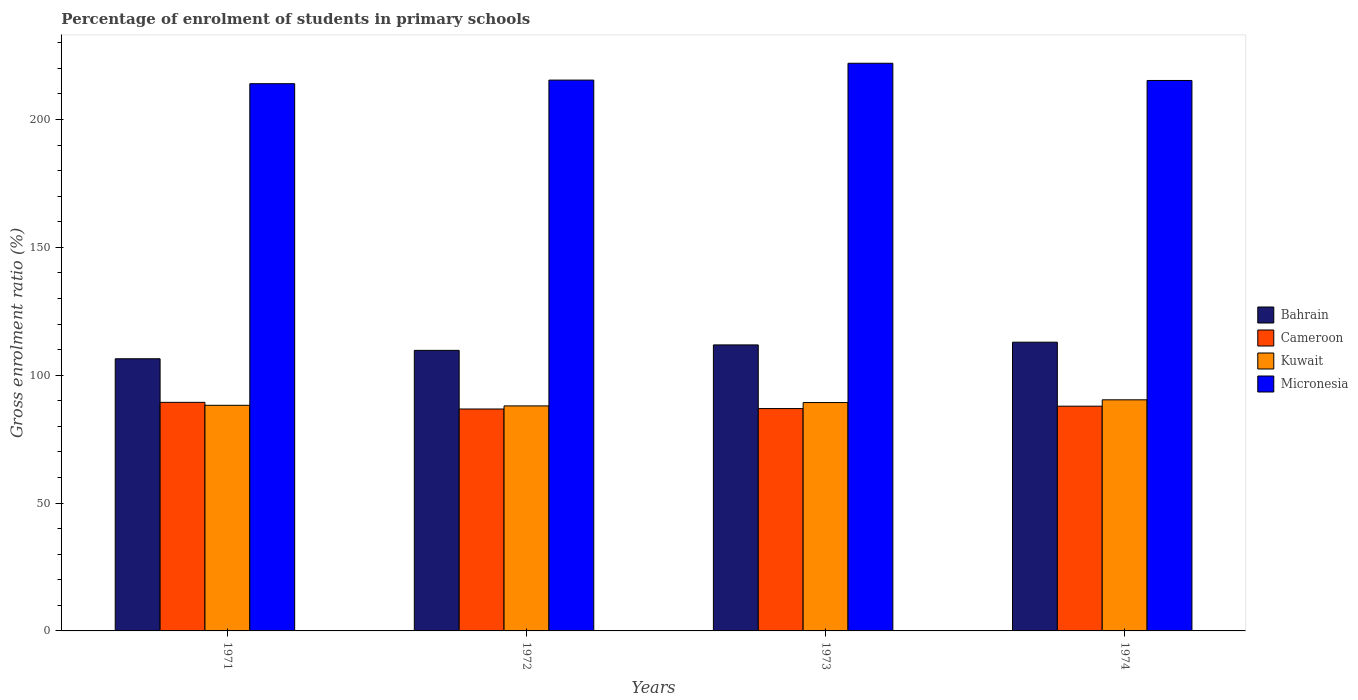How many different coloured bars are there?
Give a very brief answer. 4. Are the number of bars per tick equal to the number of legend labels?
Give a very brief answer. Yes. How many bars are there on the 4th tick from the right?
Provide a succinct answer. 4. What is the label of the 1st group of bars from the left?
Ensure brevity in your answer.  1971. What is the percentage of students enrolled in primary schools in Micronesia in 1973?
Offer a terse response. 221.99. Across all years, what is the maximum percentage of students enrolled in primary schools in Bahrain?
Keep it short and to the point. 112.91. Across all years, what is the minimum percentage of students enrolled in primary schools in Kuwait?
Keep it short and to the point. 88. In which year was the percentage of students enrolled in primary schools in Bahrain maximum?
Provide a succinct answer. 1974. In which year was the percentage of students enrolled in primary schools in Kuwait minimum?
Offer a terse response. 1972. What is the total percentage of students enrolled in primary schools in Bahrain in the graph?
Offer a terse response. 440.9. What is the difference between the percentage of students enrolled in primary schools in Cameroon in 1971 and that in 1974?
Your answer should be very brief. 1.5. What is the difference between the percentage of students enrolled in primary schools in Cameroon in 1972 and the percentage of students enrolled in primary schools in Kuwait in 1971?
Provide a succinct answer. -1.45. What is the average percentage of students enrolled in primary schools in Cameroon per year?
Ensure brevity in your answer.  87.75. In the year 1972, what is the difference between the percentage of students enrolled in primary schools in Kuwait and percentage of students enrolled in primary schools in Bahrain?
Your response must be concise. -21.72. What is the ratio of the percentage of students enrolled in primary schools in Bahrain in 1971 to that in 1972?
Provide a short and direct response. 0.97. Is the percentage of students enrolled in primary schools in Bahrain in 1971 less than that in 1972?
Offer a terse response. Yes. Is the difference between the percentage of students enrolled in primary schools in Kuwait in 1971 and 1973 greater than the difference between the percentage of students enrolled in primary schools in Bahrain in 1971 and 1973?
Keep it short and to the point. Yes. What is the difference between the highest and the second highest percentage of students enrolled in primary schools in Bahrain?
Provide a short and direct response. 1.06. What is the difference between the highest and the lowest percentage of students enrolled in primary schools in Cameroon?
Keep it short and to the point. 2.6. In how many years, is the percentage of students enrolled in primary schools in Cameroon greater than the average percentage of students enrolled in primary schools in Cameroon taken over all years?
Provide a short and direct response. 2. Is it the case that in every year, the sum of the percentage of students enrolled in primary schools in Micronesia and percentage of students enrolled in primary schools in Cameroon is greater than the sum of percentage of students enrolled in primary schools in Bahrain and percentage of students enrolled in primary schools in Kuwait?
Your answer should be compact. Yes. What does the 2nd bar from the left in 1971 represents?
Your answer should be very brief. Cameroon. What does the 1st bar from the right in 1974 represents?
Offer a very short reply. Micronesia. Are all the bars in the graph horizontal?
Offer a terse response. No. What is the difference between two consecutive major ticks on the Y-axis?
Provide a short and direct response. 50. Does the graph contain grids?
Make the answer very short. No. How many legend labels are there?
Your answer should be very brief. 4. What is the title of the graph?
Your response must be concise. Percentage of enrolment of students in primary schools. What is the label or title of the X-axis?
Provide a short and direct response. Years. What is the label or title of the Y-axis?
Give a very brief answer. Gross enrolment ratio (%). What is the Gross enrolment ratio (%) of Bahrain in 1971?
Offer a very short reply. 106.43. What is the Gross enrolment ratio (%) in Cameroon in 1971?
Give a very brief answer. 89.38. What is the Gross enrolment ratio (%) of Kuwait in 1971?
Keep it short and to the point. 88.23. What is the Gross enrolment ratio (%) of Micronesia in 1971?
Give a very brief answer. 214. What is the Gross enrolment ratio (%) in Bahrain in 1972?
Make the answer very short. 109.71. What is the Gross enrolment ratio (%) in Cameroon in 1972?
Offer a terse response. 86.78. What is the Gross enrolment ratio (%) in Kuwait in 1972?
Make the answer very short. 88. What is the Gross enrolment ratio (%) of Micronesia in 1972?
Your response must be concise. 215.41. What is the Gross enrolment ratio (%) of Bahrain in 1973?
Provide a succinct answer. 111.85. What is the Gross enrolment ratio (%) in Cameroon in 1973?
Ensure brevity in your answer.  86.95. What is the Gross enrolment ratio (%) of Kuwait in 1973?
Give a very brief answer. 89.31. What is the Gross enrolment ratio (%) in Micronesia in 1973?
Provide a succinct answer. 221.99. What is the Gross enrolment ratio (%) in Bahrain in 1974?
Make the answer very short. 112.91. What is the Gross enrolment ratio (%) in Cameroon in 1974?
Ensure brevity in your answer.  87.89. What is the Gross enrolment ratio (%) in Kuwait in 1974?
Keep it short and to the point. 90.38. What is the Gross enrolment ratio (%) in Micronesia in 1974?
Give a very brief answer. 215.26. Across all years, what is the maximum Gross enrolment ratio (%) in Bahrain?
Provide a short and direct response. 112.91. Across all years, what is the maximum Gross enrolment ratio (%) in Cameroon?
Offer a very short reply. 89.38. Across all years, what is the maximum Gross enrolment ratio (%) of Kuwait?
Provide a short and direct response. 90.38. Across all years, what is the maximum Gross enrolment ratio (%) in Micronesia?
Your answer should be compact. 221.99. Across all years, what is the minimum Gross enrolment ratio (%) of Bahrain?
Ensure brevity in your answer.  106.43. Across all years, what is the minimum Gross enrolment ratio (%) of Cameroon?
Your response must be concise. 86.78. Across all years, what is the minimum Gross enrolment ratio (%) in Kuwait?
Offer a terse response. 88. Across all years, what is the minimum Gross enrolment ratio (%) in Micronesia?
Your answer should be very brief. 214. What is the total Gross enrolment ratio (%) of Bahrain in the graph?
Offer a terse response. 440.9. What is the total Gross enrolment ratio (%) in Cameroon in the graph?
Your response must be concise. 351. What is the total Gross enrolment ratio (%) in Kuwait in the graph?
Ensure brevity in your answer.  355.91. What is the total Gross enrolment ratio (%) in Micronesia in the graph?
Make the answer very short. 866.66. What is the difference between the Gross enrolment ratio (%) of Bahrain in 1971 and that in 1972?
Your response must be concise. -3.28. What is the difference between the Gross enrolment ratio (%) in Cameroon in 1971 and that in 1972?
Provide a succinct answer. 2.6. What is the difference between the Gross enrolment ratio (%) of Kuwait in 1971 and that in 1972?
Provide a succinct answer. 0.24. What is the difference between the Gross enrolment ratio (%) in Micronesia in 1971 and that in 1972?
Your response must be concise. -1.41. What is the difference between the Gross enrolment ratio (%) of Bahrain in 1971 and that in 1973?
Ensure brevity in your answer.  -5.42. What is the difference between the Gross enrolment ratio (%) in Cameroon in 1971 and that in 1973?
Offer a terse response. 2.43. What is the difference between the Gross enrolment ratio (%) in Kuwait in 1971 and that in 1973?
Offer a very short reply. -1.07. What is the difference between the Gross enrolment ratio (%) in Micronesia in 1971 and that in 1973?
Ensure brevity in your answer.  -7.99. What is the difference between the Gross enrolment ratio (%) of Bahrain in 1971 and that in 1974?
Make the answer very short. -6.48. What is the difference between the Gross enrolment ratio (%) in Cameroon in 1971 and that in 1974?
Ensure brevity in your answer.  1.5. What is the difference between the Gross enrolment ratio (%) in Kuwait in 1971 and that in 1974?
Keep it short and to the point. -2.15. What is the difference between the Gross enrolment ratio (%) in Micronesia in 1971 and that in 1974?
Make the answer very short. -1.26. What is the difference between the Gross enrolment ratio (%) in Bahrain in 1972 and that in 1973?
Ensure brevity in your answer.  -2.14. What is the difference between the Gross enrolment ratio (%) in Cameroon in 1972 and that in 1973?
Offer a terse response. -0.18. What is the difference between the Gross enrolment ratio (%) of Kuwait in 1972 and that in 1973?
Provide a short and direct response. -1.31. What is the difference between the Gross enrolment ratio (%) of Micronesia in 1972 and that in 1973?
Make the answer very short. -6.58. What is the difference between the Gross enrolment ratio (%) of Bahrain in 1972 and that in 1974?
Ensure brevity in your answer.  -3.2. What is the difference between the Gross enrolment ratio (%) in Cameroon in 1972 and that in 1974?
Make the answer very short. -1.11. What is the difference between the Gross enrolment ratio (%) in Kuwait in 1972 and that in 1974?
Ensure brevity in your answer.  -2.38. What is the difference between the Gross enrolment ratio (%) in Micronesia in 1972 and that in 1974?
Your answer should be compact. 0.15. What is the difference between the Gross enrolment ratio (%) of Bahrain in 1973 and that in 1974?
Make the answer very short. -1.06. What is the difference between the Gross enrolment ratio (%) of Cameroon in 1973 and that in 1974?
Give a very brief answer. -0.93. What is the difference between the Gross enrolment ratio (%) in Kuwait in 1973 and that in 1974?
Provide a succinct answer. -1.07. What is the difference between the Gross enrolment ratio (%) of Micronesia in 1973 and that in 1974?
Provide a succinct answer. 6.74. What is the difference between the Gross enrolment ratio (%) in Bahrain in 1971 and the Gross enrolment ratio (%) in Cameroon in 1972?
Give a very brief answer. 19.65. What is the difference between the Gross enrolment ratio (%) in Bahrain in 1971 and the Gross enrolment ratio (%) in Kuwait in 1972?
Ensure brevity in your answer.  18.44. What is the difference between the Gross enrolment ratio (%) in Bahrain in 1971 and the Gross enrolment ratio (%) in Micronesia in 1972?
Your answer should be compact. -108.98. What is the difference between the Gross enrolment ratio (%) in Cameroon in 1971 and the Gross enrolment ratio (%) in Kuwait in 1972?
Make the answer very short. 1.39. What is the difference between the Gross enrolment ratio (%) of Cameroon in 1971 and the Gross enrolment ratio (%) of Micronesia in 1972?
Offer a terse response. -126.03. What is the difference between the Gross enrolment ratio (%) of Kuwait in 1971 and the Gross enrolment ratio (%) of Micronesia in 1972?
Keep it short and to the point. -127.18. What is the difference between the Gross enrolment ratio (%) in Bahrain in 1971 and the Gross enrolment ratio (%) in Cameroon in 1973?
Your response must be concise. 19.48. What is the difference between the Gross enrolment ratio (%) in Bahrain in 1971 and the Gross enrolment ratio (%) in Kuwait in 1973?
Offer a very short reply. 17.12. What is the difference between the Gross enrolment ratio (%) in Bahrain in 1971 and the Gross enrolment ratio (%) in Micronesia in 1973?
Ensure brevity in your answer.  -115.56. What is the difference between the Gross enrolment ratio (%) of Cameroon in 1971 and the Gross enrolment ratio (%) of Kuwait in 1973?
Provide a succinct answer. 0.08. What is the difference between the Gross enrolment ratio (%) in Cameroon in 1971 and the Gross enrolment ratio (%) in Micronesia in 1973?
Your response must be concise. -132.61. What is the difference between the Gross enrolment ratio (%) of Kuwait in 1971 and the Gross enrolment ratio (%) of Micronesia in 1973?
Your response must be concise. -133.76. What is the difference between the Gross enrolment ratio (%) in Bahrain in 1971 and the Gross enrolment ratio (%) in Cameroon in 1974?
Keep it short and to the point. 18.54. What is the difference between the Gross enrolment ratio (%) of Bahrain in 1971 and the Gross enrolment ratio (%) of Kuwait in 1974?
Offer a terse response. 16.05. What is the difference between the Gross enrolment ratio (%) of Bahrain in 1971 and the Gross enrolment ratio (%) of Micronesia in 1974?
Make the answer very short. -108.83. What is the difference between the Gross enrolment ratio (%) in Cameroon in 1971 and the Gross enrolment ratio (%) in Kuwait in 1974?
Give a very brief answer. -1. What is the difference between the Gross enrolment ratio (%) in Cameroon in 1971 and the Gross enrolment ratio (%) in Micronesia in 1974?
Provide a succinct answer. -125.87. What is the difference between the Gross enrolment ratio (%) in Kuwait in 1971 and the Gross enrolment ratio (%) in Micronesia in 1974?
Your answer should be compact. -127.02. What is the difference between the Gross enrolment ratio (%) in Bahrain in 1972 and the Gross enrolment ratio (%) in Cameroon in 1973?
Keep it short and to the point. 22.76. What is the difference between the Gross enrolment ratio (%) of Bahrain in 1972 and the Gross enrolment ratio (%) of Kuwait in 1973?
Provide a short and direct response. 20.4. What is the difference between the Gross enrolment ratio (%) in Bahrain in 1972 and the Gross enrolment ratio (%) in Micronesia in 1973?
Your answer should be very brief. -112.28. What is the difference between the Gross enrolment ratio (%) of Cameroon in 1972 and the Gross enrolment ratio (%) of Kuwait in 1973?
Offer a terse response. -2.53. What is the difference between the Gross enrolment ratio (%) in Cameroon in 1972 and the Gross enrolment ratio (%) in Micronesia in 1973?
Ensure brevity in your answer.  -135.21. What is the difference between the Gross enrolment ratio (%) of Kuwait in 1972 and the Gross enrolment ratio (%) of Micronesia in 1973?
Provide a short and direct response. -134. What is the difference between the Gross enrolment ratio (%) in Bahrain in 1972 and the Gross enrolment ratio (%) in Cameroon in 1974?
Provide a succinct answer. 21.83. What is the difference between the Gross enrolment ratio (%) in Bahrain in 1972 and the Gross enrolment ratio (%) in Kuwait in 1974?
Your answer should be very brief. 19.33. What is the difference between the Gross enrolment ratio (%) of Bahrain in 1972 and the Gross enrolment ratio (%) of Micronesia in 1974?
Offer a terse response. -105.55. What is the difference between the Gross enrolment ratio (%) in Cameroon in 1972 and the Gross enrolment ratio (%) in Kuwait in 1974?
Ensure brevity in your answer.  -3.6. What is the difference between the Gross enrolment ratio (%) of Cameroon in 1972 and the Gross enrolment ratio (%) of Micronesia in 1974?
Keep it short and to the point. -128.48. What is the difference between the Gross enrolment ratio (%) of Kuwait in 1972 and the Gross enrolment ratio (%) of Micronesia in 1974?
Your answer should be very brief. -127.26. What is the difference between the Gross enrolment ratio (%) in Bahrain in 1973 and the Gross enrolment ratio (%) in Cameroon in 1974?
Your answer should be compact. 23.96. What is the difference between the Gross enrolment ratio (%) of Bahrain in 1973 and the Gross enrolment ratio (%) of Kuwait in 1974?
Your answer should be very brief. 21.47. What is the difference between the Gross enrolment ratio (%) of Bahrain in 1973 and the Gross enrolment ratio (%) of Micronesia in 1974?
Your answer should be compact. -103.41. What is the difference between the Gross enrolment ratio (%) of Cameroon in 1973 and the Gross enrolment ratio (%) of Kuwait in 1974?
Offer a terse response. -3.42. What is the difference between the Gross enrolment ratio (%) in Cameroon in 1973 and the Gross enrolment ratio (%) in Micronesia in 1974?
Keep it short and to the point. -128.3. What is the difference between the Gross enrolment ratio (%) of Kuwait in 1973 and the Gross enrolment ratio (%) of Micronesia in 1974?
Your response must be concise. -125.95. What is the average Gross enrolment ratio (%) in Bahrain per year?
Give a very brief answer. 110.22. What is the average Gross enrolment ratio (%) in Cameroon per year?
Make the answer very short. 87.75. What is the average Gross enrolment ratio (%) in Kuwait per year?
Make the answer very short. 88.98. What is the average Gross enrolment ratio (%) of Micronesia per year?
Your answer should be compact. 216.66. In the year 1971, what is the difference between the Gross enrolment ratio (%) of Bahrain and Gross enrolment ratio (%) of Cameroon?
Your answer should be compact. 17.05. In the year 1971, what is the difference between the Gross enrolment ratio (%) of Bahrain and Gross enrolment ratio (%) of Kuwait?
Your response must be concise. 18.2. In the year 1971, what is the difference between the Gross enrolment ratio (%) of Bahrain and Gross enrolment ratio (%) of Micronesia?
Provide a succinct answer. -107.57. In the year 1971, what is the difference between the Gross enrolment ratio (%) of Cameroon and Gross enrolment ratio (%) of Kuwait?
Give a very brief answer. 1.15. In the year 1971, what is the difference between the Gross enrolment ratio (%) of Cameroon and Gross enrolment ratio (%) of Micronesia?
Offer a terse response. -124.62. In the year 1971, what is the difference between the Gross enrolment ratio (%) in Kuwait and Gross enrolment ratio (%) in Micronesia?
Provide a succinct answer. -125.77. In the year 1972, what is the difference between the Gross enrolment ratio (%) in Bahrain and Gross enrolment ratio (%) in Cameroon?
Offer a very short reply. 22.93. In the year 1972, what is the difference between the Gross enrolment ratio (%) in Bahrain and Gross enrolment ratio (%) in Kuwait?
Your answer should be compact. 21.72. In the year 1972, what is the difference between the Gross enrolment ratio (%) of Bahrain and Gross enrolment ratio (%) of Micronesia?
Ensure brevity in your answer.  -105.7. In the year 1972, what is the difference between the Gross enrolment ratio (%) in Cameroon and Gross enrolment ratio (%) in Kuwait?
Ensure brevity in your answer.  -1.22. In the year 1972, what is the difference between the Gross enrolment ratio (%) in Cameroon and Gross enrolment ratio (%) in Micronesia?
Offer a terse response. -128.63. In the year 1972, what is the difference between the Gross enrolment ratio (%) of Kuwait and Gross enrolment ratio (%) of Micronesia?
Your answer should be very brief. -127.41. In the year 1973, what is the difference between the Gross enrolment ratio (%) in Bahrain and Gross enrolment ratio (%) in Cameroon?
Make the answer very short. 24.89. In the year 1973, what is the difference between the Gross enrolment ratio (%) of Bahrain and Gross enrolment ratio (%) of Kuwait?
Your response must be concise. 22.54. In the year 1973, what is the difference between the Gross enrolment ratio (%) of Bahrain and Gross enrolment ratio (%) of Micronesia?
Your response must be concise. -110.14. In the year 1973, what is the difference between the Gross enrolment ratio (%) in Cameroon and Gross enrolment ratio (%) in Kuwait?
Keep it short and to the point. -2.35. In the year 1973, what is the difference between the Gross enrolment ratio (%) in Cameroon and Gross enrolment ratio (%) in Micronesia?
Provide a succinct answer. -135.04. In the year 1973, what is the difference between the Gross enrolment ratio (%) of Kuwait and Gross enrolment ratio (%) of Micronesia?
Your answer should be compact. -132.69. In the year 1974, what is the difference between the Gross enrolment ratio (%) in Bahrain and Gross enrolment ratio (%) in Cameroon?
Keep it short and to the point. 25.02. In the year 1974, what is the difference between the Gross enrolment ratio (%) in Bahrain and Gross enrolment ratio (%) in Kuwait?
Provide a succinct answer. 22.53. In the year 1974, what is the difference between the Gross enrolment ratio (%) of Bahrain and Gross enrolment ratio (%) of Micronesia?
Ensure brevity in your answer.  -102.35. In the year 1974, what is the difference between the Gross enrolment ratio (%) in Cameroon and Gross enrolment ratio (%) in Kuwait?
Ensure brevity in your answer.  -2.49. In the year 1974, what is the difference between the Gross enrolment ratio (%) in Cameroon and Gross enrolment ratio (%) in Micronesia?
Keep it short and to the point. -127.37. In the year 1974, what is the difference between the Gross enrolment ratio (%) in Kuwait and Gross enrolment ratio (%) in Micronesia?
Provide a short and direct response. -124.88. What is the ratio of the Gross enrolment ratio (%) of Bahrain in 1971 to that in 1972?
Provide a succinct answer. 0.97. What is the ratio of the Gross enrolment ratio (%) in Micronesia in 1971 to that in 1972?
Provide a succinct answer. 0.99. What is the ratio of the Gross enrolment ratio (%) in Bahrain in 1971 to that in 1973?
Your answer should be compact. 0.95. What is the ratio of the Gross enrolment ratio (%) of Cameroon in 1971 to that in 1973?
Provide a succinct answer. 1.03. What is the ratio of the Gross enrolment ratio (%) in Kuwait in 1971 to that in 1973?
Provide a succinct answer. 0.99. What is the ratio of the Gross enrolment ratio (%) in Bahrain in 1971 to that in 1974?
Keep it short and to the point. 0.94. What is the ratio of the Gross enrolment ratio (%) of Cameroon in 1971 to that in 1974?
Your response must be concise. 1.02. What is the ratio of the Gross enrolment ratio (%) of Kuwait in 1971 to that in 1974?
Provide a short and direct response. 0.98. What is the ratio of the Gross enrolment ratio (%) in Micronesia in 1971 to that in 1974?
Offer a terse response. 0.99. What is the ratio of the Gross enrolment ratio (%) in Bahrain in 1972 to that in 1973?
Your response must be concise. 0.98. What is the ratio of the Gross enrolment ratio (%) of Micronesia in 1972 to that in 1973?
Offer a terse response. 0.97. What is the ratio of the Gross enrolment ratio (%) in Bahrain in 1972 to that in 1974?
Ensure brevity in your answer.  0.97. What is the ratio of the Gross enrolment ratio (%) of Cameroon in 1972 to that in 1974?
Your answer should be very brief. 0.99. What is the ratio of the Gross enrolment ratio (%) of Kuwait in 1972 to that in 1974?
Offer a terse response. 0.97. What is the ratio of the Gross enrolment ratio (%) in Micronesia in 1972 to that in 1974?
Make the answer very short. 1. What is the ratio of the Gross enrolment ratio (%) of Bahrain in 1973 to that in 1974?
Your response must be concise. 0.99. What is the ratio of the Gross enrolment ratio (%) of Micronesia in 1973 to that in 1974?
Offer a very short reply. 1.03. What is the difference between the highest and the second highest Gross enrolment ratio (%) of Bahrain?
Provide a succinct answer. 1.06. What is the difference between the highest and the second highest Gross enrolment ratio (%) in Cameroon?
Offer a terse response. 1.5. What is the difference between the highest and the second highest Gross enrolment ratio (%) in Kuwait?
Provide a succinct answer. 1.07. What is the difference between the highest and the second highest Gross enrolment ratio (%) in Micronesia?
Keep it short and to the point. 6.58. What is the difference between the highest and the lowest Gross enrolment ratio (%) in Bahrain?
Offer a very short reply. 6.48. What is the difference between the highest and the lowest Gross enrolment ratio (%) in Cameroon?
Your answer should be compact. 2.6. What is the difference between the highest and the lowest Gross enrolment ratio (%) in Kuwait?
Give a very brief answer. 2.38. What is the difference between the highest and the lowest Gross enrolment ratio (%) in Micronesia?
Give a very brief answer. 7.99. 